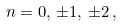Convert formula to latex. <formula><loc_0><loc_0><loc_500><loc_500>n = 0 , \, \pm 1 , \, \pm 2 \, ,</formula> 